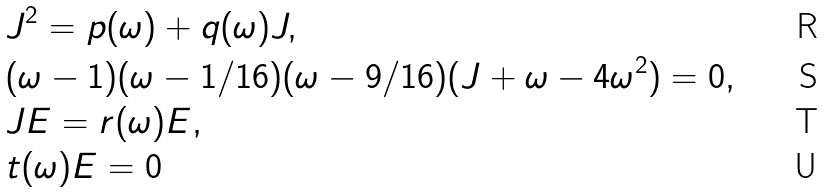Convert formula to latex. <formula><loc_0><loc_0><loc_500><loc_500>& J ^ { 2 } = p ( \omega ) + q ( \omega ) J , \\ & ( \omega - 1 ) ( \omega - 1 / 1 6 ) ( \omega - 9 / 1 6 ) ( J + \omega - 4 \omega ^ { 2 } ) = 0 , \\ & J E = r ( \omega ) E , \\ & t ( \omega ) E = 0</formula> 